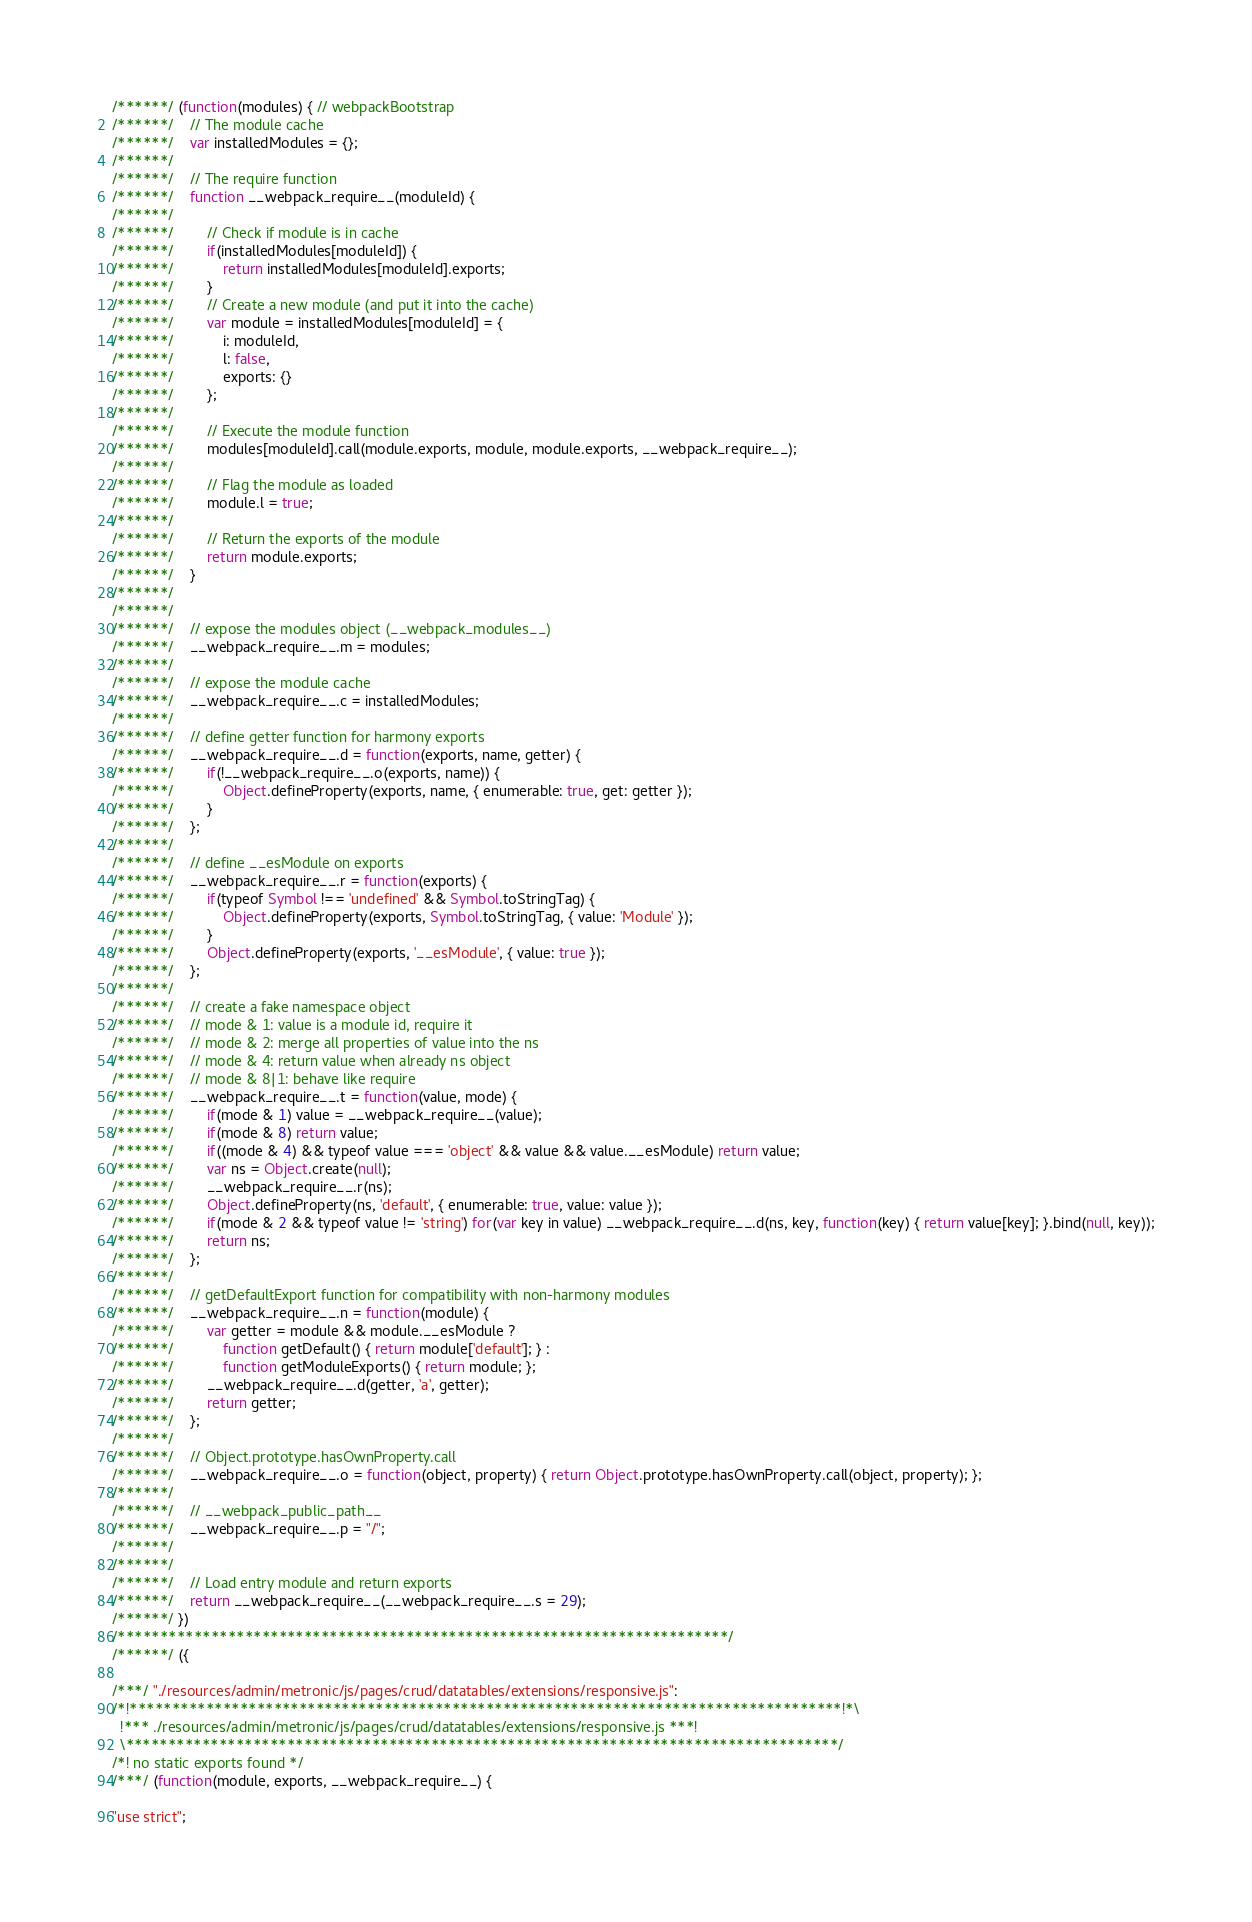Convert code to text. <code><loc_0><loc_0><loc_500><loc_500><_JavaScript_>/******/ (function(modules) { // webpackBootstrap
/******/ 	// The module cache
/******/ 	var installedModules = {};
/******/
/******/ 	// The require function
/******/ 	function __webpack_require__(moduleId) {
/******/
/******/ 		// Check if module is in cache
/******/ 		if(installedModules[moduleId]) {
/******/ 			return installedModules[moduleId].exports;
/******/ 		}
/******/ 		// Create a new module (and put it into the cache)
/******/ 		var module = installedModules[moduleId] = {
/******/ 			i: moduleId,
/******/ 			l: false,
/******/ 			exports: {}
/******/ 		};
/******/
/******/ 		// Execute the module function
/******/ 		modules[moduleId].call(module.exports, module, module.exports, __webpack_require__);
/******/
/******/ 		// Flag the module as loaded
/******/ 		module.l = true;
/******/
/******/ 		// Return the exports of the module
/******/ 		return module.exports;
/******/ 	}
/******/
/******/
/******/ 	// expose the modules object (__webpack_modules__)
/******/ 	__webpack_require__.m = modules;
/******/
/******/ 	// expose the module cache
/******/ 	__webpack_require__.c = installedModules;
/******/
/******/ 	// define getter function for harmony exports
/******/ 	__webpack_require__.d = function(exports, name, getter) {
/******/ 		if(!__webpack_require__.o(exports, name)) {
/******/ 			Object.defineProperty(exports, name, { enumerable: true, get: getter });
/******/ 		}
/******/ 	};
/******/
/******/ 	// define __esModule on exports
/******/ 	__webpack_require__.r = function(exports) {
/******/ 		if(typeof Symbol !== 'undefined' && Symbol.toStringTag) {
/******/ 			Object.defineProperty(exports, Symbol.toStringTag, { value: 'Module' });
/******/ 		}
/******/ 		Object.defineProperty(exports, '__esModule', { value: true });
/******/ 	};
/******/
/******/ 	// create a fake namespace object
/******/ 	// mode & 1: value is a module id, require it
/******/ 	// mode & 2: merge all properties of value into the ns
/******/ 	// mode & 4: return value when already ns object
/******/ 	// mode & 8|1: behave like require
/******/ 	__webpack_require__.t = function(value, mode) {
/******/ 		if(mode & 1) value = __webpack_require__(value);
/******/ 		if(mode & 8) return value;
/******/ 		if((mode & 4) && typeof value === 'object' && value && value.__esModule) return value;
/******/ 		var ns = Object.create(null);
/******/ 		__webpack_require__.r(ns);
/******/ 		Object.defineProperty(ns, 'default', { enumerable: true, value: value });
/******/ 		if(mode & 2 && typeof value != 'string') for(var key in value) __webpack_require__.d(ns, key, function(key) { return value[key]; }.bind(null, key));
/******/ 		return ns;
/******/ 	};
/******/
/******/ 	// getDefaultExport function for compatibility with non-harmony modules
/******/ 	__webpack_require__.n = function(module) {
/******/ 		var getter = module && module.__esModule ?
/******/ 			function getDefault() { return module['default']; } :
/******/ 			function getModuleExports() { return module; };
/******/ 		__webpack_require__.d(getter, 'a', getter);
/******/ 		return getter;
/******/ 	};
/******/
/******/ 	// Object.prototype.hasOwnProperty.call
/******/ 	__webpack_require__.o = function(object, property) { return Object.prototype.hasOwnProperty.call(object, property); };
/******/
/******/ 	// __webpack_public_path__
/******/ 	__webpack_require__.p = "/";
/******/
/******/
/******/ 	// Load entry module and return exports
/******/ 	return __webpack_require__(__webpack_require__.s = 29);
/******/ })
/************************************************************************/
/******/ ({

/***/ "./resources/admin/metronic/js/pages/crud/datatables/extensions/responsive.js":
/*!************************************************************************************!*\
  !*** ./resources/admin/metronic/js/pages/crud/datatables/extensions/responsive.js ***!
  \************************************************************************************/
/*! no static exports found */
/***/ (function(module, exports, __webpack_require__) {

"use strict";</code> 